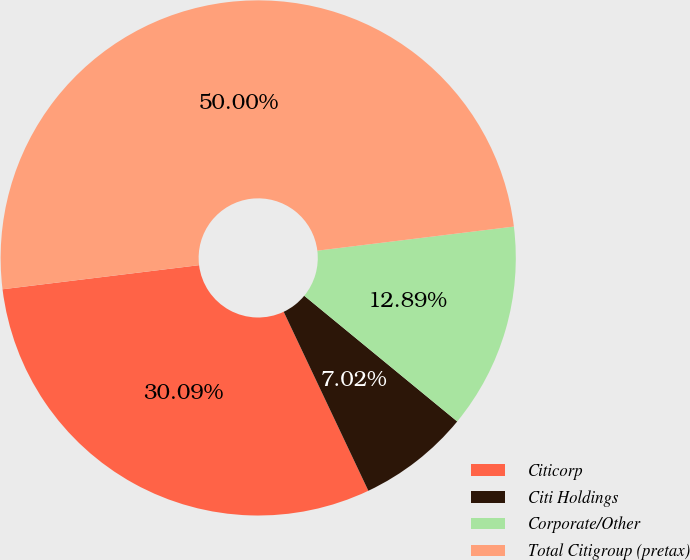Convert chart to OTSL. <chart><loc_0><loc_0><loc_500><loc_500><pie_chart><fcel>Citicorp<fcel>Citi Holdings<fcel>Corporate/Other<fcel>Total Citigroup (pretax)<nl><fcel>30.09%<fcel>7.02%<fcel>12.89%<fcel>50.0%<nl></chart> 